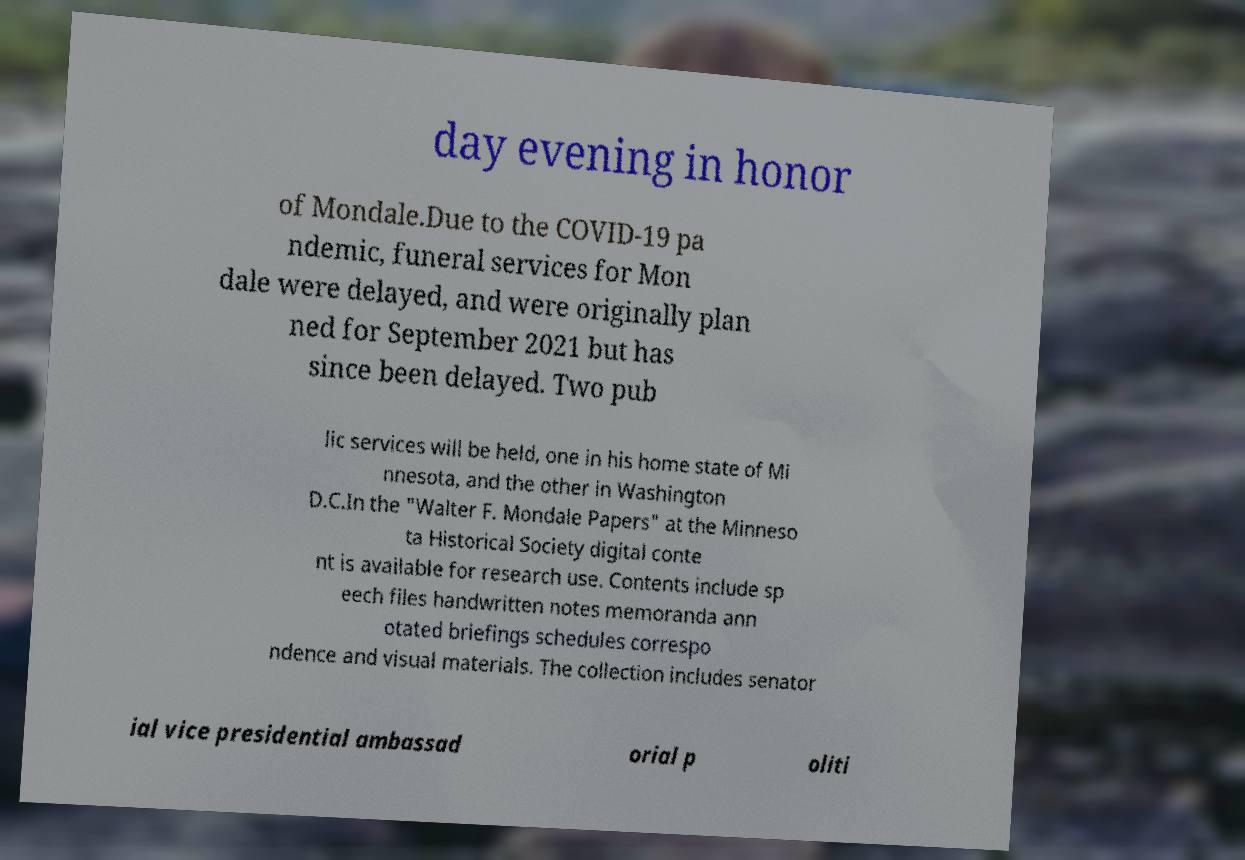Can you accurately transcribe the text from the provided image for me? day evening in honor of Mondale.Due to the COVID-19 pa ndemic, funeral services for Mon dale were delayed, and were originally plan ned for September 2021 but has since been delayed. Two pub lic services will be held, one in his home state of Mi nnesota, and the other in Washington D.C.In the "Walter F. Mondale Papers" at the Minneso ta Historical Society digital conte nt is available for research use. Contents include sp eech files handwritten notes memoranda ann otated briefings schedules correspo ndence and visual materials. The collection includes senator ial vice presidential ambassad orial p oliti 